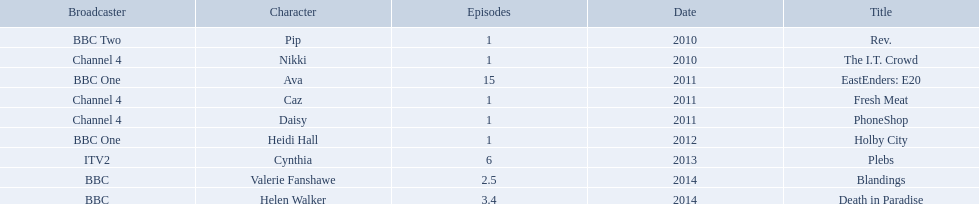Which characters were featured in more then one episode? Ava, Cynthia, Valerie Fanshawe, Helen Walker. Which of these were not in 2014? Ava, Cynthia. Which one of those was not on a bbc broadcaster? Cynthia. What roles did she play? Pip, Nikki, Ava, Caz, Daisy, Heidi Hall, Cynthia, Valerie Fanshawe, Helen Walker. On which broadcasters? BBC Two, Channel 4, BBC One, Channel 4, Channel 4, BBC One, ITV2, BBC, BBC. Which roles did she play for itv2? Cynthia. 